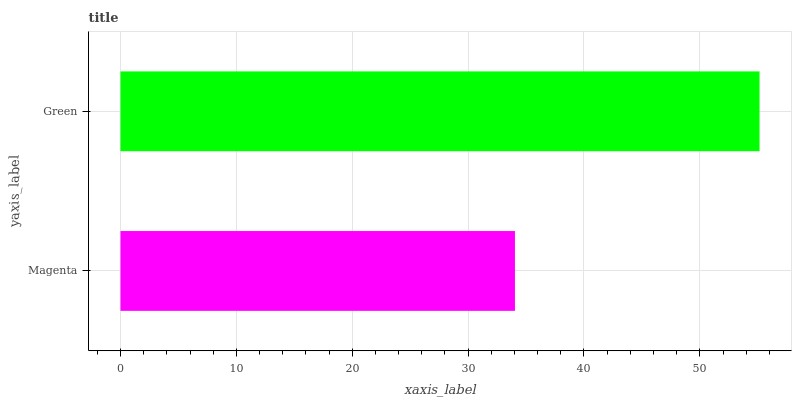Is Magenta the minimum?
Answer yes or no. Yes. Is Green the maximum?
Answer yes or no. Yes. Is Green the minimum?
Answer yes or no. No. Is Green greater than Magenta?
Answer yes or no. Yes. Is Magenta less than Green?
Answer yes or no. Yes. Is Magenta greater than Green?
Answer yes or no. No. Is Green less than Magenta?
Answer yes or no. No. Is Green the high median?
Answer yes or no. Yes. Is Magenta the low median?
Answer yes or no. Yes. Is Magenta the high median?
Answer yes or no. No. Is Green the low median?
Answer yes or no. No. 